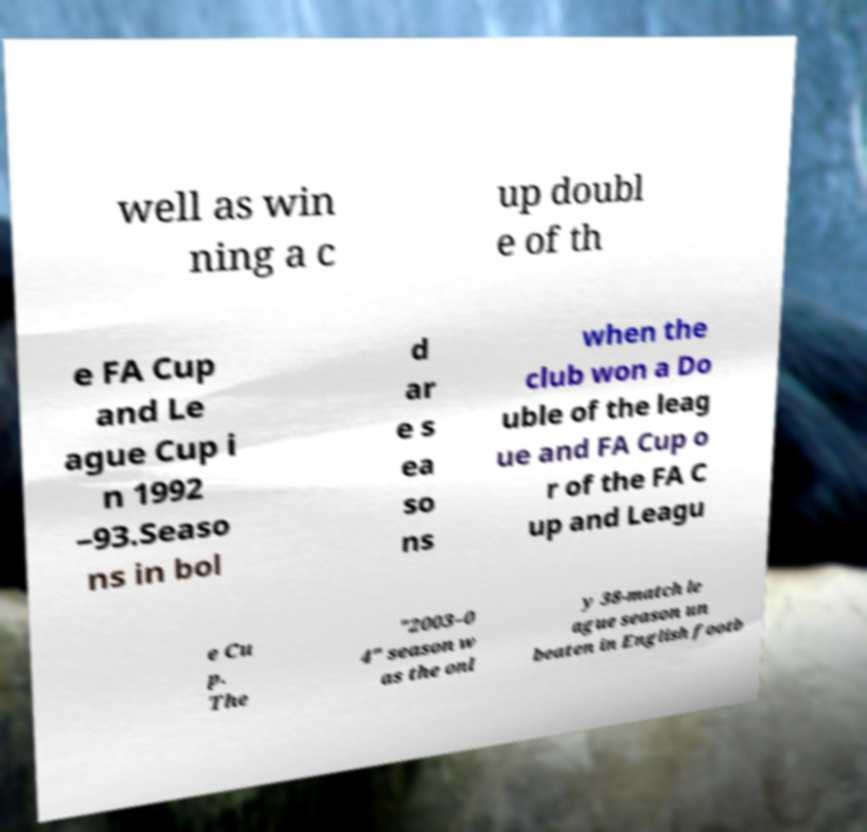Could you extract and type out the text from this image? well as win ning a c up doubl e of th e FA Cup and Le ague Cup i n 1992 –93.Seaso ns in bol d ar e s ea so ns when the club won a Do uble of the leag ue and FA Cup o r of the FA C up and Leagu e Cu p. The "2003–0 4" season w as the onl y 38-match le ague season un beaten in English footb 